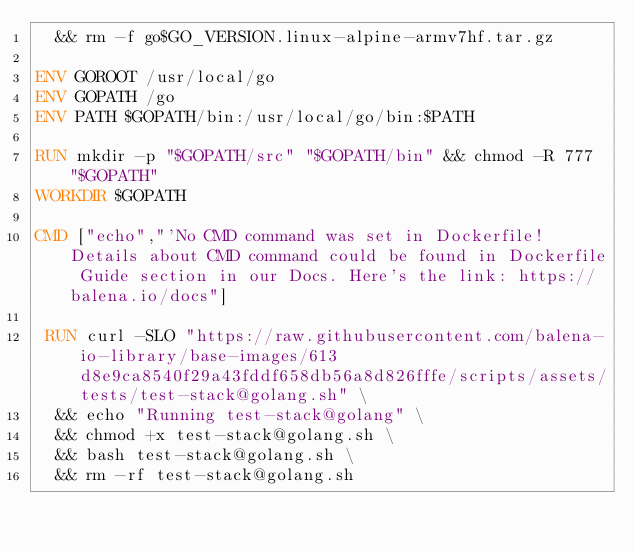Convert code to text. <code><loc_0><loc_0><loc_500><loc_500><_Dockerfile_>	&& rm -f go$GO_VERSION.linux-alpine-armv7hf.tar.gz

ENV GOROOT /usr/local/go
ENV GOPATH /go
ENV PATH $GOPATH/bin:/usr/local/go/bin:$PATH

RUN mkdir -p "$GOPATH/src" "$GOPATH/bin" && chmod -R 777 "$GOPATH"
WORKDIR $GOPATH

CMD ["echo","'No CMD command was set in Dockerfile! Details about CMD command could be found in Dockerfile Guide section in our Docs. Here's the link: https://balena.io/docs"]

 RUN curl -SLO "https://raw.githubusercontent.com/balena-io-library/base-images/613d8e9ca8540f29a43fddf658db56a8d826fffe/scripts/assets/tests/test-stack@golang.sh" \
  && echo "Running test-stack@golang" \
  && chmod +x test-stack@golang.sh \
  && bash test-stack@golang.sh \
  && rm -rf test-stack@golang.sh 
</code> 